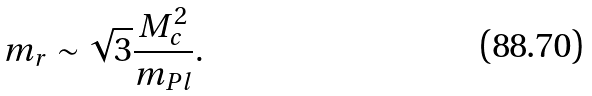Convert formula to latex. <formula><loc_0><loc_0><loc_500><loc_500>m _ { r } \sim \sqrt { 3 } \frac { M _ { c } ^ { 2 } } { m _ { P l } } .</formula> 